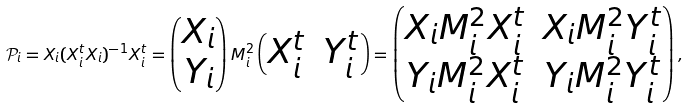Convert formula to latex. <formula><loc_0><loc_0><loc_500><loc_500>\mathcal { P } _ { i } = X _ { i } ( X _ { i } ^ { t } X _ { i } ) ^ { - 1 } X _ { i } ^ { t } = \begin{pmatrix} X _ { i } \\ Y _ { i } \end{pmatrix} M _ { i } ^ { 2 } \begin{pmatrix} X _ { i } ^ { t } & Y _ { i } ^ { t } \end{pmatrix} = \begin{pmatrix} X _ { i } M _ { i } ^ { 2 } X _ { i } ^ { t } & X _ { i } M _ { i } ^ { 2 } Y _ { i } ^ { t } \\ Y _ { i } M _ { i } ^ { 2 } X _ { i } ^ { t } & Y _ { i } M _ { i } ^ { 2 } Y _ { i } ^ { t } \end{pmatrix} ,</formula> 